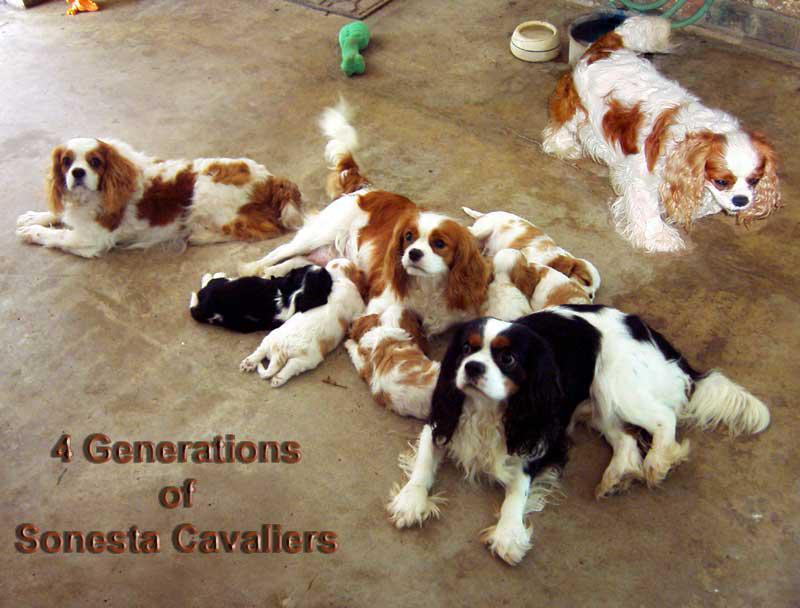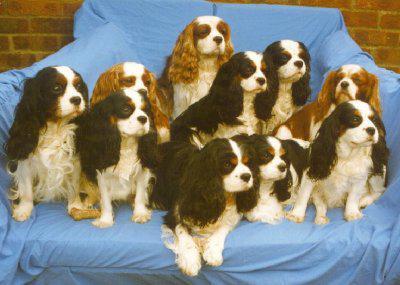The first image is the image on the left, the second image is the image on the right. Considering the images on both sides, is "There are 5 dogs shown." valid? Answer yes or no. No. The first image is the image on the left, the second image is the image on the right. Considering the images on both sides, is "There are five dogs in total, with more dogs on the right." valid? Answer yes or no. No. 